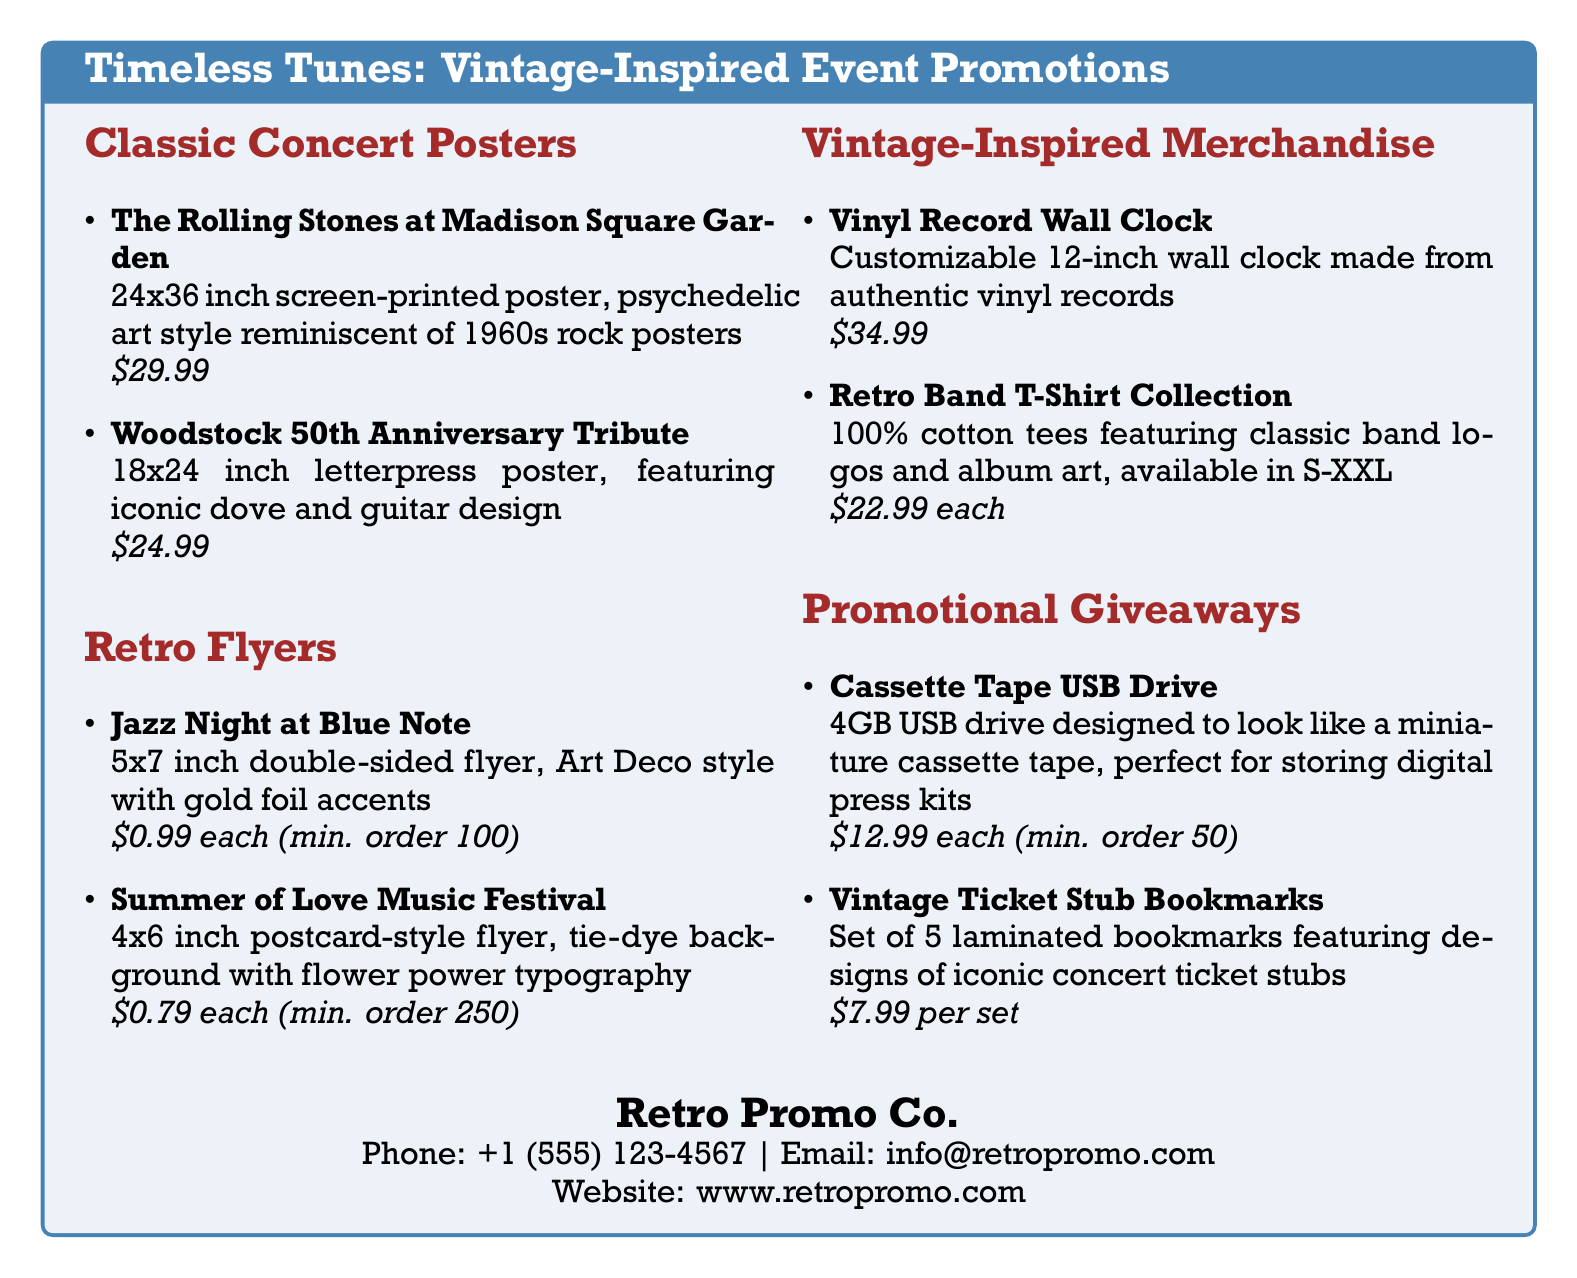What size is the Rolling Stones poster? The size of the Rolling Stones poster is specified in the document as 24x36 inches.
Answer: 24x36 inch What is the price of the Woodstock poster? The document lists the price of the Woodstock poster as $24.99.
Answer: $24.99 What type of flyer is for Jazz Night at Blue Note? The document describes the Jazz Night flyer as a 5x7 inch double-sided flyer in Art Deco style.
Answer: 5x7 inch double-sided How much does each retro band t-shirt cost? The price for each retro band t-shirt is stated as $22.99 in the catalog.
Answer: $22.99 What is the minimum order for the cassette tape USB drives? The document notes that the minimum order for cassette tape USB drives is 50 units.
Answer: 50 Which concert event is associated with the Summer of Love flyer? The Summer of Love flyer is linked to the Summer of Love Music Festival as mentioned in the document.
Answer: Summer of Love Music Festival What is the theme of the Vintage Ticket Stub Bookmarks? The design theme of the Vintage Ticket Stub Bookmarks features iconic concert ticket stubs.
Answer: iconic concert ticket stubs What material is the Vinyl Record Wall Clock made from? The document states that the Vinyl Record Wall Clock is made from authentic vinyl records.
Answer: authentic vinyl records What size do the band t-shirts come in? The available sizes for the band t-shirts are noted as S-XXL in the promotional material.
Answer: S-XXL 